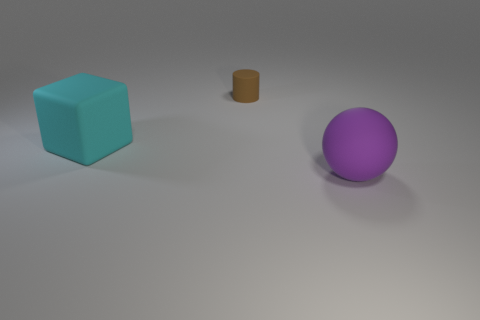Is the number of brown rubber cylinders in front of the small brown object the same as the number of small green metal things?
Your answer should be very brief. Yes. There is a matte thing on the right side of the brown cylinder; how big is it?
Provide a short and direct response. Large. There is a thing that is both in front of the tiny matte cylinder and to the left of the purple rubber ball; what is its material?
Ensure brevity in your answer.  Rubber. Does the purple ball have the same material as the brown thing?
Offer a very short reply. Yes. How many big red metallic spheres are there?
Your answer should be compact. 0. The large rubber thing that is left of the big thing in front of the big matte object on the left side of the large rubber ball is what color?
Give a very brief answer. Cyan. Is the large rubber block the same color as the rubber cylinder?
Your response must be concise. No. How many objects are behind the ball and to the right of the cyan matte thing?
Offer a very short reply. 1. How many metallic things are either brown cylinders or balls?
Offer a terse response. 0. The large thing behind the large object in front of the cyan object is made of what material?
Offer a terse response. Rubber. 